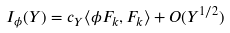Convert formula to latex. <formula><loc_0><loc_0><loc_500><loc_500>I _ { \phi } ( Y ) = c _ { Y } \langle \phi F _ { k } , F _ { k } \rangle + O ( Y ^ { 1 / 2 } )</formula> 